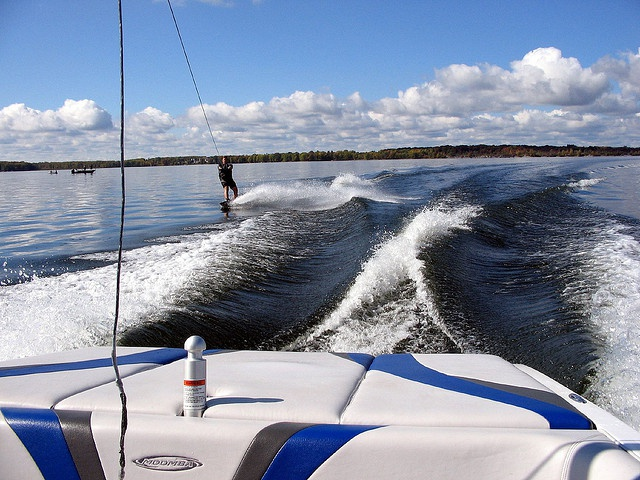Describe the objects in this image and their specific colors. I can see boat in gray, lightgray, navy, and darkgray tones, people in gray, black, darkgray, and lightpink tones, boat in gray, black, and darkgray tones, surfboard in gray and black tones, and people in black and gray tones in this image. 